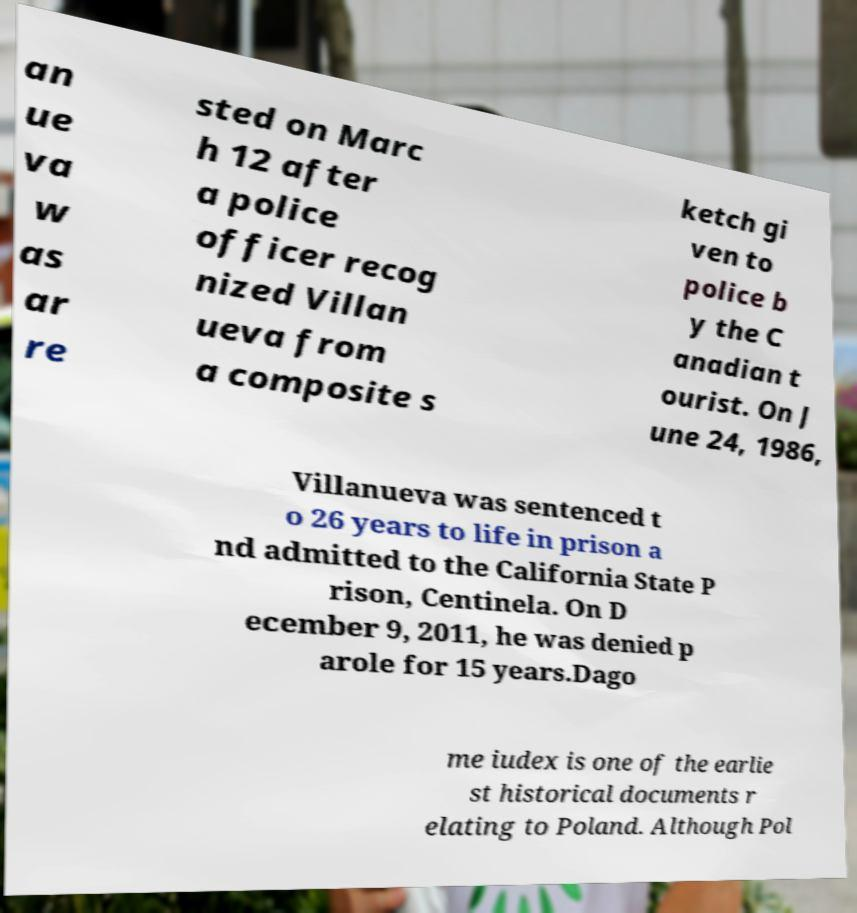What messages or text are displayed in this image? I need them in a readable, typed format. an ue va w as ar re sted on Marc h 12 after a police officer recog nized Villan ueva from a composite s ketch gi ven to police b y the C anadian t ourist. On J une 24, 1986, Villanueva was sentenced t o 26 years to life in prison a nd admitted to the California State P rison, Centinela. On D ecember 9, 2011, he was denied p arole for 15 years.Dago me iudex is one of the earlie st historical documents r elating to Poland. Although Pol 